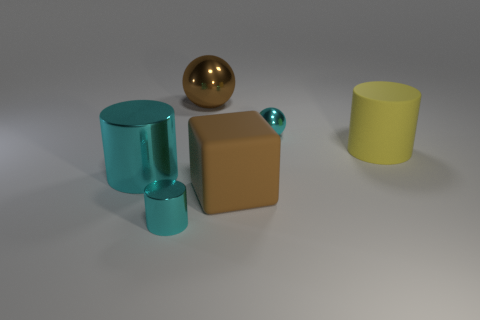Subtract all large rubber cylinders. How many cylinders are left? 2 Subtract all purple cubes. How many cyan cylinders are left? 2 Add 1 matte objects. How many objects exist? 7 Subtract 1 balls. How many balls are left? 1 Subtract all yellow cylinders. How many cylinders are left? 2 Subtract all cubes. How many objects are left? 5 Subtract 0 purple cubes. How many objects are left? 6 Subtract all green spheres. Subtract all green blocks. How many spheres are left? 2 Subtract all gray cubes. Subtract all cyan metal objects. How many objects are left? 3 Add 1 big cyan shiny cylinders. How many big cyan shiny cylinders are left? 2 